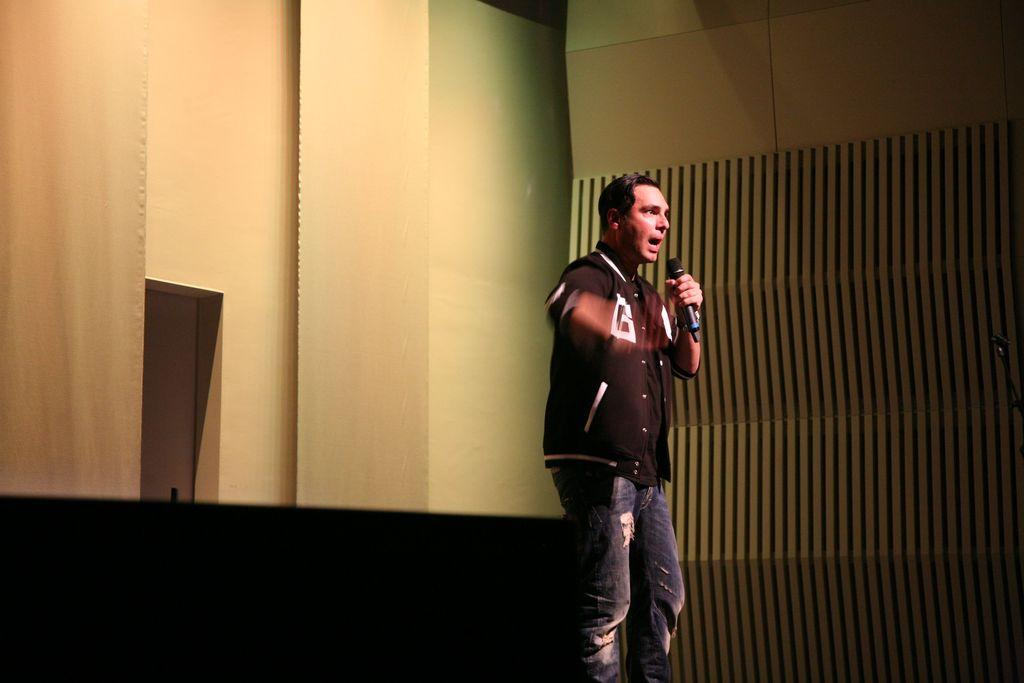What is the main subject of the image? There is a person in the image. What is the person wearing? The person is wearing a black shirt and blue jeans. What is the person doing in the image? The person is standing and holding a microphone. What can be seen in the background of the image? There is a wall in the background of the image. Can you see a kite flying in the image? No, there is no kite present in the image. Is the person in the image a minister? The provided facts do not mention the person's occupation or title, so we cannot determine if they are a minister. 